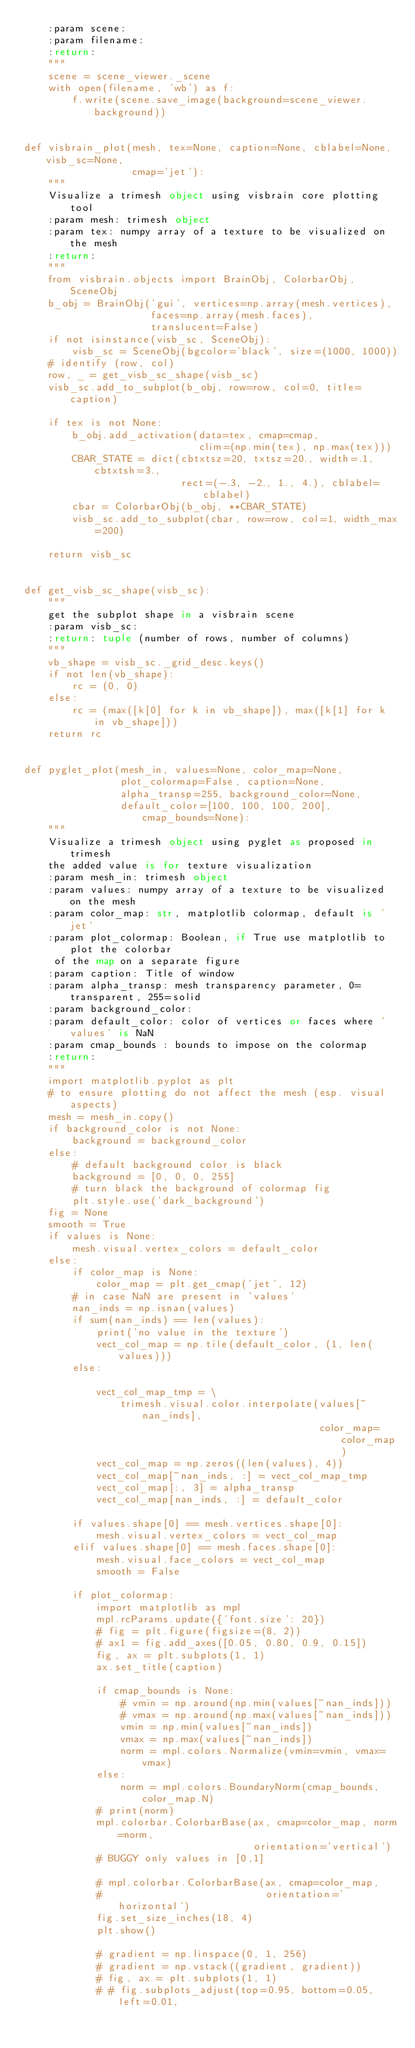Convert code to text. <code><loc_0><loc_0><loc_500><loc_500><_Python_>    :param scene:
    :param filename:
    :return:
    """
    scene = scene_viewer._scene
    with open(filename, 'wb') as f:
        f.write(scene.save_image(background=scene_viewer.background))


def visbrain_plot(mesh, tex=None, caption=None, cblabel=None, visb_sc=None,
                  cmap='jet'):
    """
    Visualize a trimesh object using visbrain core plotting tool
    :param mesh: trimesh object
    :param tex: numpy array of a texture to be visualized on the mesh
    :return:
    """
    from visbrain.objects import BrainObj, ColorbarObj, SceneObj
    b_obj = BrainObj('gui', vertices=np.array(mesh.vertices),
                     faces=np.array(mesh.faces),
                     translucent=False)
    if not isinstance(visb_sc, SceneObj):
        visb_sc = SceneObj(bgcolor='black', size=(1000, 1000))
    # identify (row, col)
    row, _ = get_visb_sc_shape(visb_sc)
    visb_sc.add_to_subplot(b_obj, row=row, col=0, title=caption)

    if tex is not None:
        b_obj.add_activation(data=tex, cmap=cmap,
                             clim=(np.min(tex), np.max(tex)))
        CBAR_STATE = dict(cbtxtsz=20, txtsz=20., width=.1, cbtxtsh=3.,
                          rect=(-.3, -2., 1., 4.), cblabel=cblabel)
        cbar = ColorbarObj(b_obj, **CBAR_STATE)
        visb_sc.add_to_subplot(cbar, row=row, col=1, width_max=200)

    return visb_sc


def get_visb_sc_shape(visb_sc):
    """
    get the subplot shape in a visbrain scene
    :param visb_sc:
    :return: tuple (number of rows, number of columns)
    """
    vb_shape = visb_sc._grid_desc.keys()
    if not len(vb_shape):
        rc = (0, 0)
    else:
        rc = (max([k[0] for k in vb_shape]), max([k[1] for k in vb_shape]))
    return rc


def pyglet_plot(mesh_in, values=None, color_map=None,
                plot_colormap=False, caption=None,
                alpha_transp=255, background_color=None,
                default_color=[100, 100, 100, 200], cmap_bounds=None):
    """
    Visualize a trimesh object using pyglet as proposed in trimesh
    the added value is for texture visualization
    :param mesh_in: trimesh object
    :param values: numpy array of a texture to be visualized on the mesh
    :param color_map: str, matplotlib colormap, default is 'jet'
    :param plot_colormap: Boolean, if True use matplotlib to plot the colorbar
     of the map on a separate figure
    :param caption: Title of window
    :param alpha_transp: mesh transparency parameter, 0=transparent, 255=solid
    :param background_color:
    :param default_color: color of vertices or faces where 'values' is NaN
    :param cmap_bounds : bounds to impose on the colormap
    :return:
    """
    import matplotlib.pyplot as plt
    # to ensure plotting do not affect the mesh (esp. visual aspects)
    mesh = mesh_in.copy()
    if background_color is not None:
        background = background_color
    else:
        # default background color is black
        background = [0, 0, 0, 255]
        # turn black the background of colormap fig
        plt.style.use('dark_background')
    fig = None
    smooth = True
    if values is None:
        mesh.visual.vertex_colors = default_color
    else:
        if color_map is None:
            color_map = plt.get_cmap('jet', 12)
        # in case NaN are present in 'values'
        nan_inds = np.isnan(values)
        if sum(nan_inds) == len(values):
            print('no value in the texture')
            vect_col_map = np.tile(default_color, (1, len(values)))
        else:

            vect_col_map_tmp = \
                trimesh.visual.color.interpolate(values[~nan_inds],
                                                 color_map=color_map)
            vect_col_map = np.zeros((len(values), 4))
            vect_col_map[~nan_inds, :] = vect_col_map_tmp
            vect_col_map[:, 3] = alpha_transp
            vect_col_map[nan_inds, :] = default_color

        if values.shape[0] == mesh.vertices.shape[0]:
            mesh.visual.vertex_colors = vect_col_map
        elif values.shape[0] == mesh.faces.shape[0]:
            mesh.visual.face_colors = vect_col_map
            smooth = False

        if plot_colormap:
            import matplotlib as mpl
            mpl.rcParams.update({'font.size': 20})
            # fig = plt.figure(figsize=(8, 2))
            # ax1 = fig.add_axes([0.05, 0.80, 0.9, 0.15])
            fig, ax = plt.subplots(1, 1)
            ax.set_title(caption)

            if cmap_bounds is None:
                # vmin = np.around(np.min(values[~nan_inds]))
                # vmax = np.around(np.max(values[~nan_inds]))
                vmin = np.min(values[~nan_inds])
                vmax = np.max(values[~nan_inds])
                norm = mpl.colors.Normalize(vmin=vmin, vmax=vmax)
            else:
                norm = mpl.colors.BoundaryNorm(cmap_bounds, color_map.N)
            # print(norm)
            mpl.colorbar.ColorbarBase(ax, cmap=color_map, norm=norm,
                                      orientation='vertical')
            # BUGGY only values in [0,1]

            # mpl.colorbar.ColorbarBase(ax, cmap=color_map,
            #                           orientation='horizontal')
            fig.set_size_inches(18, 4)
            plt.show()

            # gradient = np.linspace(0, 1, 256)
            # gradient = np.vstack((gradient, gradient))
            # fig, ax = plt.subplots(1, 1)
            # # fig.subplots_adjust(top=0.95, bottom=0.05, left=0.01,</code> 